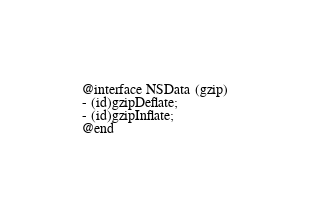Convert code to text. <code><loc_0><loc_0><loc_500><loc_500><_C_>
@interface NSData (gzip)
- (id)gzipDeflate;
- (id)gzipInflate;
@end

</code> 